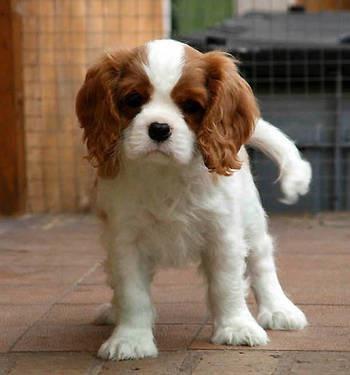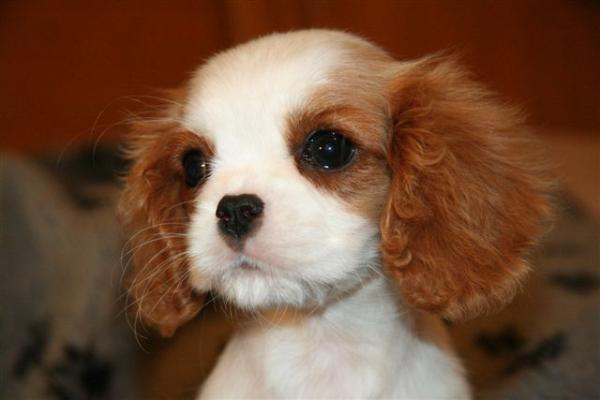The first image is the image on the left, the second image is the image on the right. Given the left and right images, does the statement "There are no more than three animals" hold true? Answer yes or no. Yes. The first image is the image on the left, the second image is the image on the right. For the images shown, is this caption "Someone is holding up at least one of the puppies." true? Answer yes or no. No. The first image is the image on the left, the second image is the image on the right. Given the left and right images, does the statement "Human hands hold at least one puppy in one image." hold true? Answer yes or no. No. 